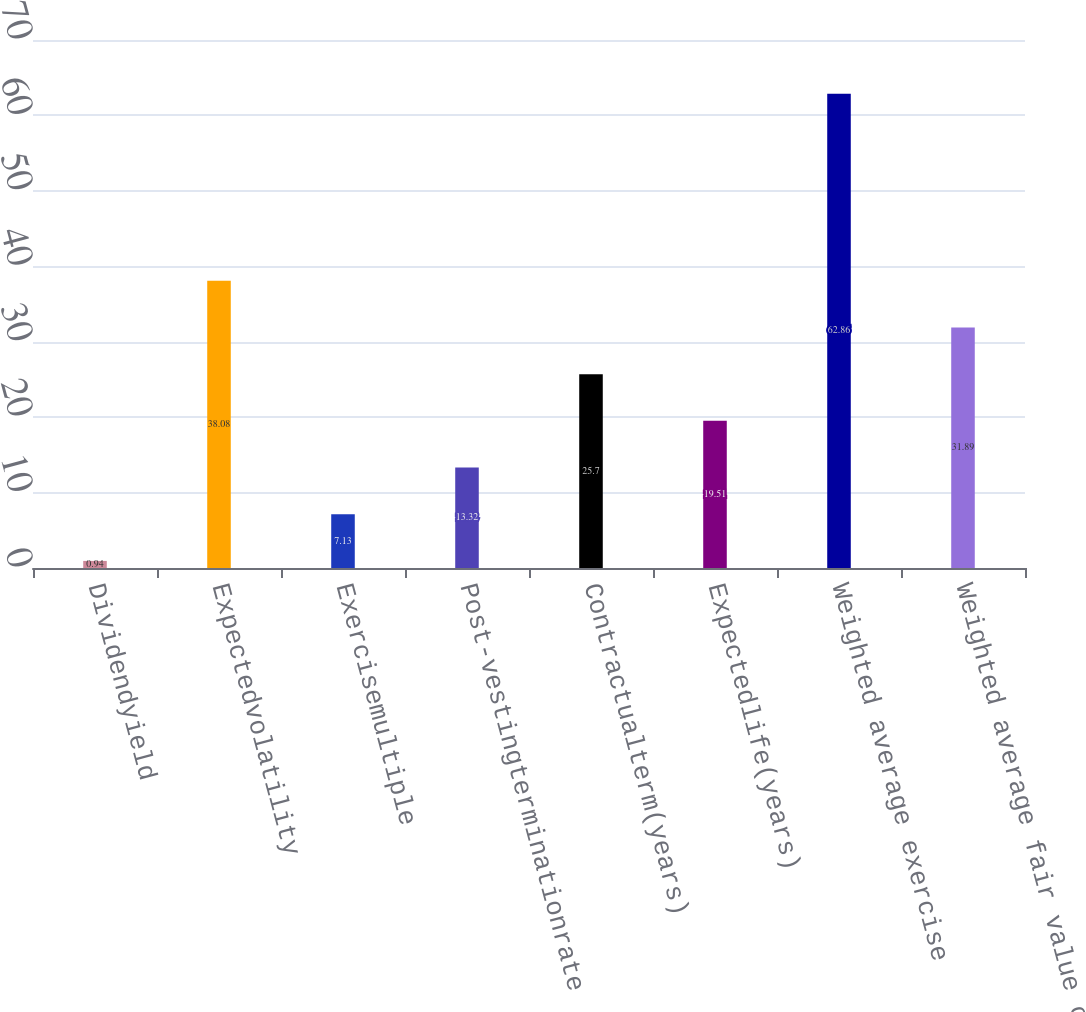Convert chart to OTSL. <chart><loc_0><loc_0><loc_500><loc_500><bar_chart><fcel>Dividendyield<fcel>Expectedvolatility<fcel>Exercisemultiple<fcel>Post-vestingterminationrate<fcel>Contractualterm(years)<fcel>Expectedlife(years)<fcel>Weighted average exercise<fcel>Weighted average fair value of<nl><fcel>0.94<fcel>38.08<fcel>7.13<fcel>13.32<fcel>25.7<fcel>19.51<fcel>62.86<fcel>31.89<nl></chart> 